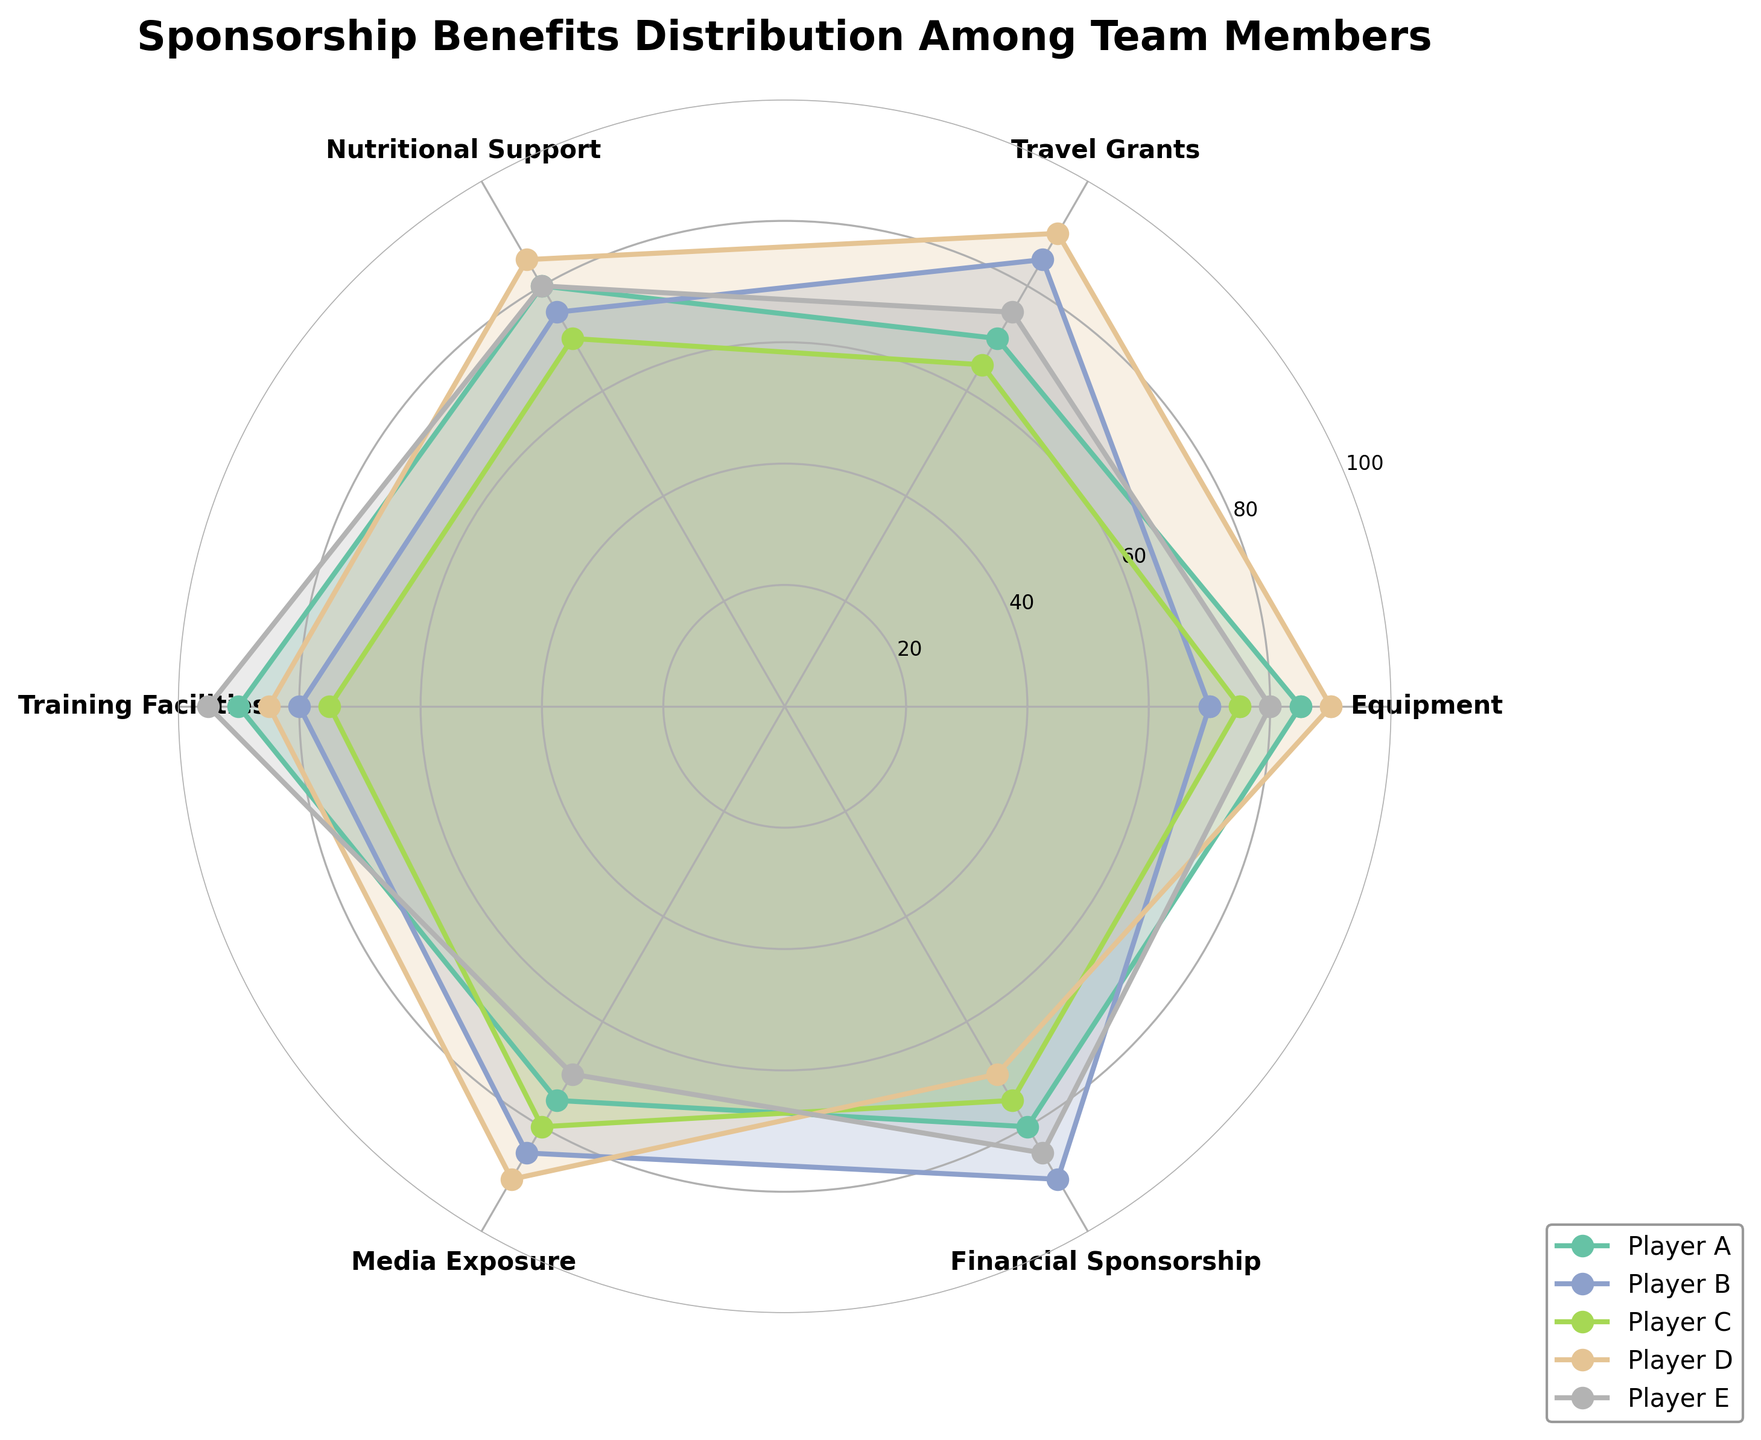What's the title of the radar chart? The title of the radar chart is usually written at the top of the figure.
Answer: Sponsorship Benefits Distribution Among Team Members How many categories are assessed in the radar chart? Count the number of labeled axes radiating from the center of the radar chart.
Answer: 6 Which player has the highest score in Training Facilities? Look at the values on the axis labeled "Training Facilities" and identify which player's data line reaches the highest value.
Answer: Player E What is the average value of Player A across all categories? Add the values for Player A in all categories and divide by the number of categories: (85 + 70 + 80 + 90 + 75 + 80) / 6.
Answer: 80 Which category does Player D score the least in? Find the lowest value on Player D's radar chart line and identify the corresponding category.
Answer: Financial Sponsorship Who has a higher score in Media Exposure, Player B or Player C? Compare the values for Media Exposure for Player B and Player C, identifying which is higher.
Answer: Player B What is the difference between the highest and lowest value for Player C? Identify the highest and lowest values in Player C's data, then subtract the lowest value from the highest value: 80 - 65.
Answer: 15 Which players score equally in Nutritional Support? Look at the Nutritional Support values and identify any players with the same score of 80.
Answer: Player A and Player E In how many categories does Player B have the highest score compared to other players? Compare Player B's values with those of other players for each category to count how many times Player B has the highest value.
Answer: 2 Which player shows the most balanced distribution across all categories? Identify the player whose radar chart line maintains relatively similar distances from the center across all categories, indicating a balanced distribution.
Answer: Player A 